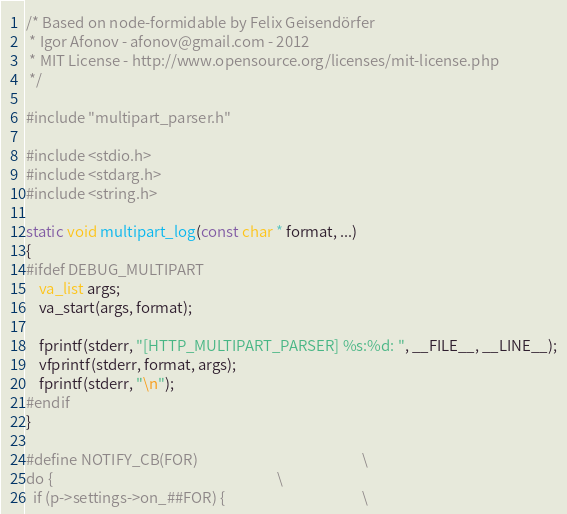Convert code to text. <code><loc_0><loc_0><loc_500><loc_500><_C_>/* Based on node-formidable by Felix Geisendörfer 
 * Igor Afonov - afonov@gmail.com - 2012
 * MIT License - http://www.opensource.org/licenses/mit-license.php
 */

#include "multipart_parser.h"

#include <stdio.h>
#include <stdarg.h>
#include <string.h>

static void multipart_log(const char * format, ...)
{
#ifdef DEBUG_MULTIPART
    va_list args;
    va_start(args, format);

    fprintf(stderr, "[HTTP_MULTIPART_PARSER] %s:%d: ", __FILE__, __LINE__);
    vfprintf(stderr, format, args);
    fprintf(stderr, "\n");
#endif
}

#define NOTIFY_CB(FOR)                                                 \
do {                                                                   \
  if (p->settings->on_##FOR) {                                         \</code> 